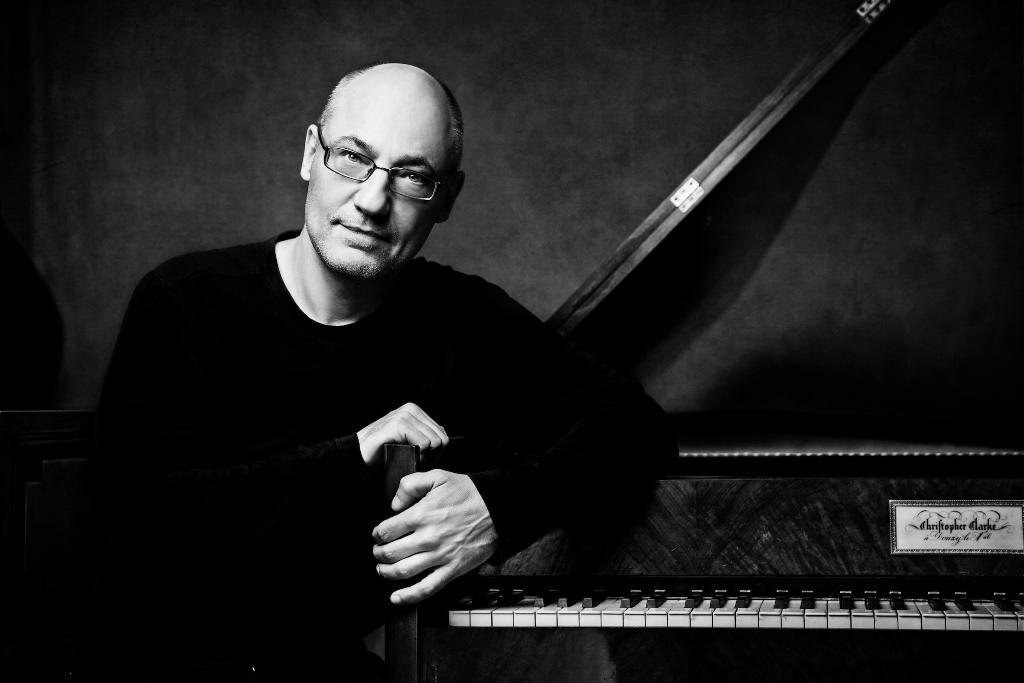What is the main subject of the image? There is a person in the image. What is the person holding in the image? The person is holding a musical instrument. What is the person's posture in the image? The person is sitting on a chair. What type of agreement is the person signing in the image? There is no agreement or signing activity present in the image. Can you tell me how many bananas are visible in the image? There are no bananas present in the image. 